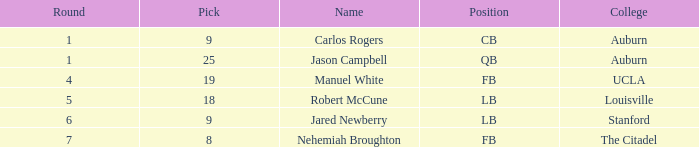Which college had an overall pick of 9? Auburn. Parse the full table. {'header': ['Round', 'Pick', 'Name', 'Position', 'College'], 'rows': [['1', '9', 'Carlos Rogers', 'CB', 'Auburn'], ['1', '25', 'Jason Campbell', 'QB', 'Auburn'], ['4', '19', 'Manuel White', 'FB', 'UCLA'], ['5', '18', 'Robert McCune', 'LB', 'Louisville'], ['6', '9', 'Jared Newberry', 'LB', 'Stanford'], ['7', '8', 'Nehemiah Broughton', 'FB', 'The Citadel']]} 